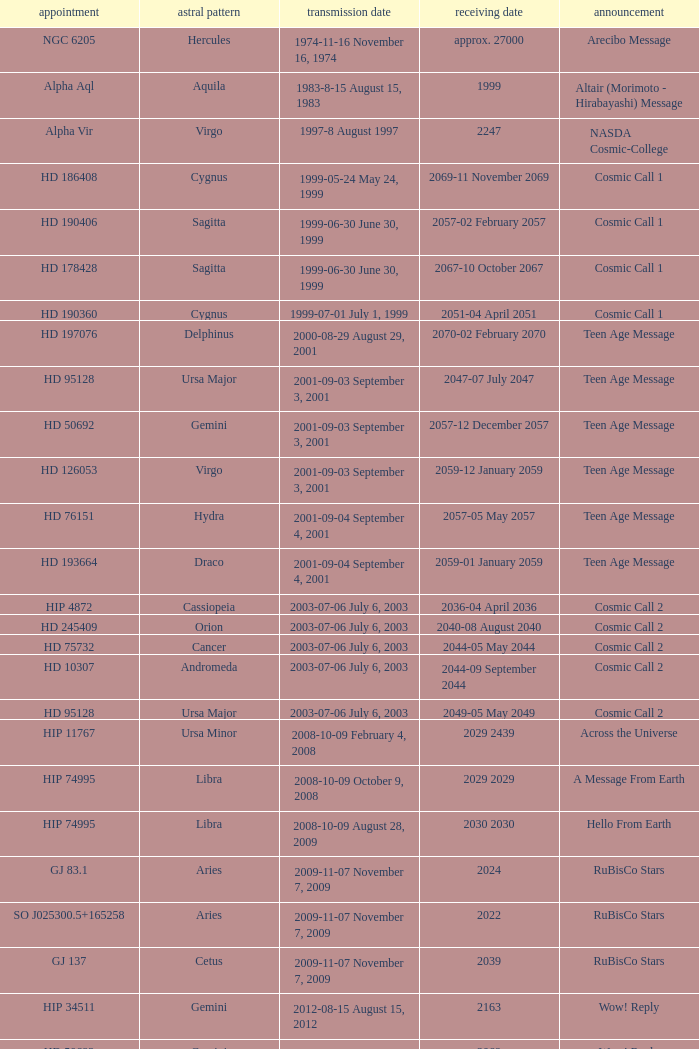Where is Hip 4872? Cassiopeia. 